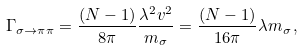Convert formula to latex. <formula><loc_0><loc_0><loc_500><loc_500>\Gamma _ { \sigma \rightarrow \pi \pi } = \frac { ( N - 1 ) } { 8 \pi } \frac { \lambda ^ { 2 } v ^ { 2 } } { m _ { \sigma } } = \frac { ( N - 1 ) } { 1 6 \pi } \lambda m _ { \sigma } \, ,</formula> 